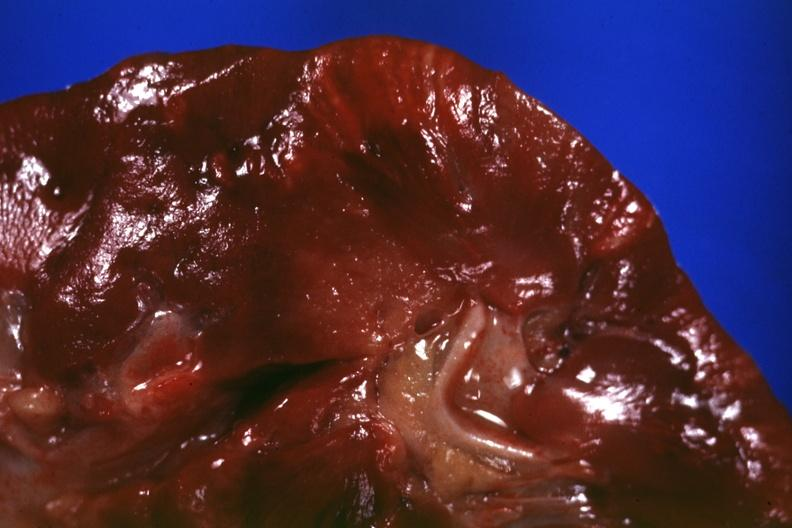does digital infarcts bacterial endocarditis show cut surface?
Answer the question using a single word or phrase. No 